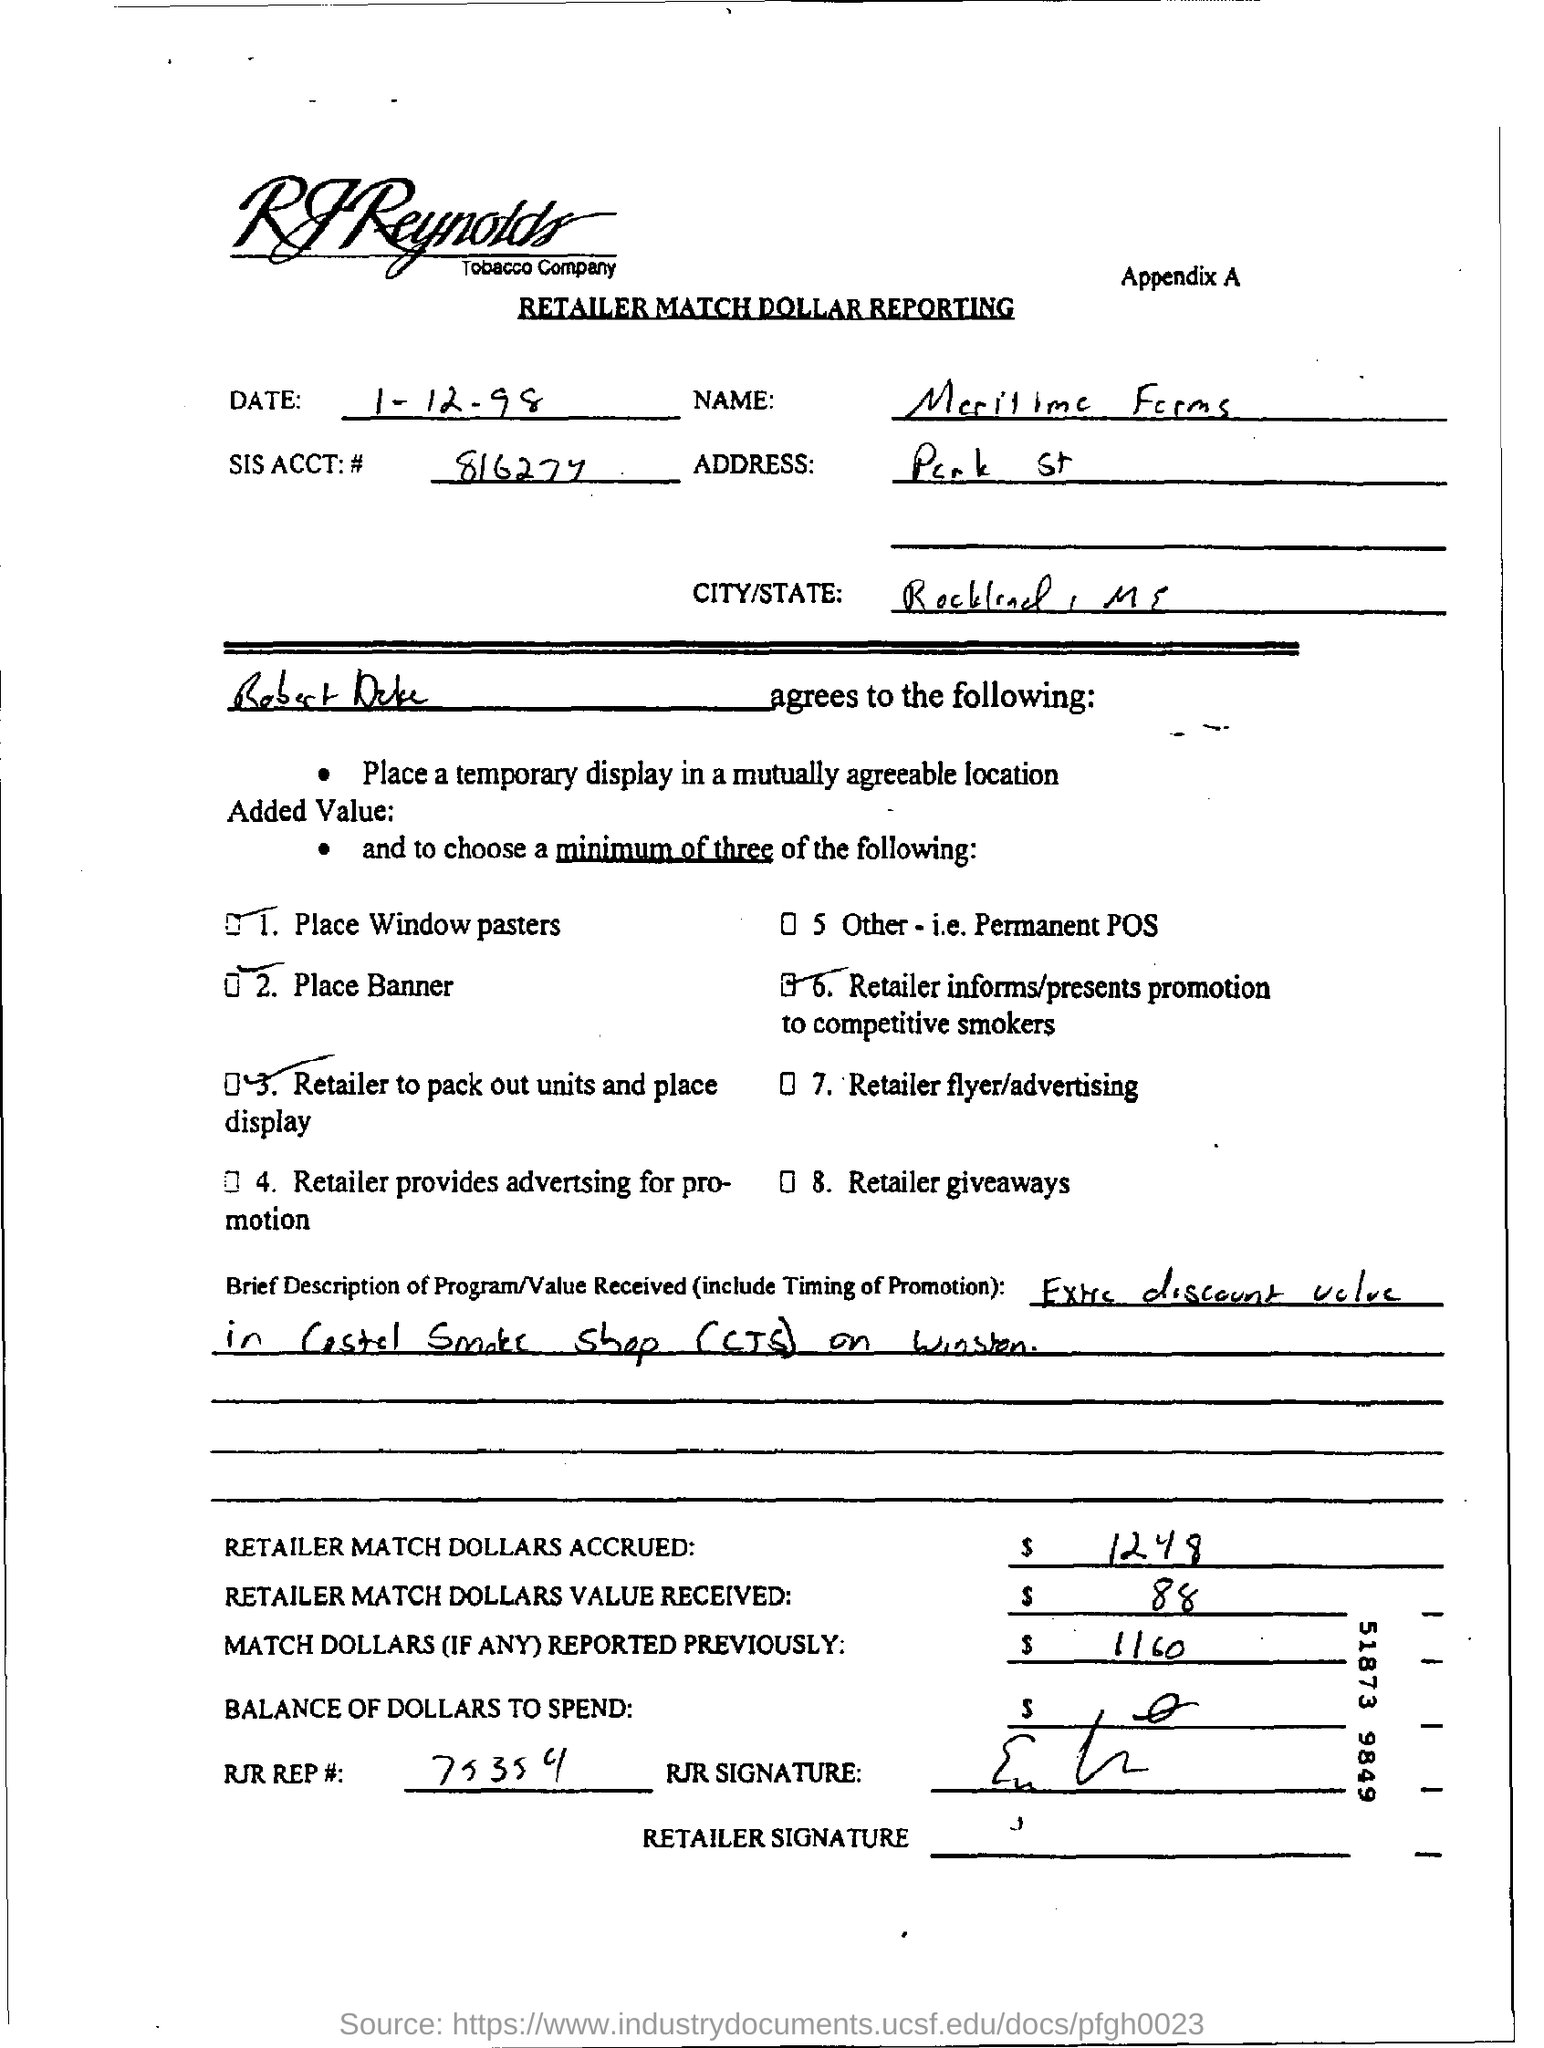Which series of appendix is this paper
Your answer should be very brief. Appendix A. 